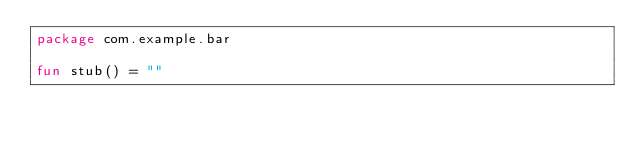Convert code to text. <code><loc_0><loc_0><loc_500><loc_500><_Kotlin_>package com.example.bar

fun stub() = ""
</code> 